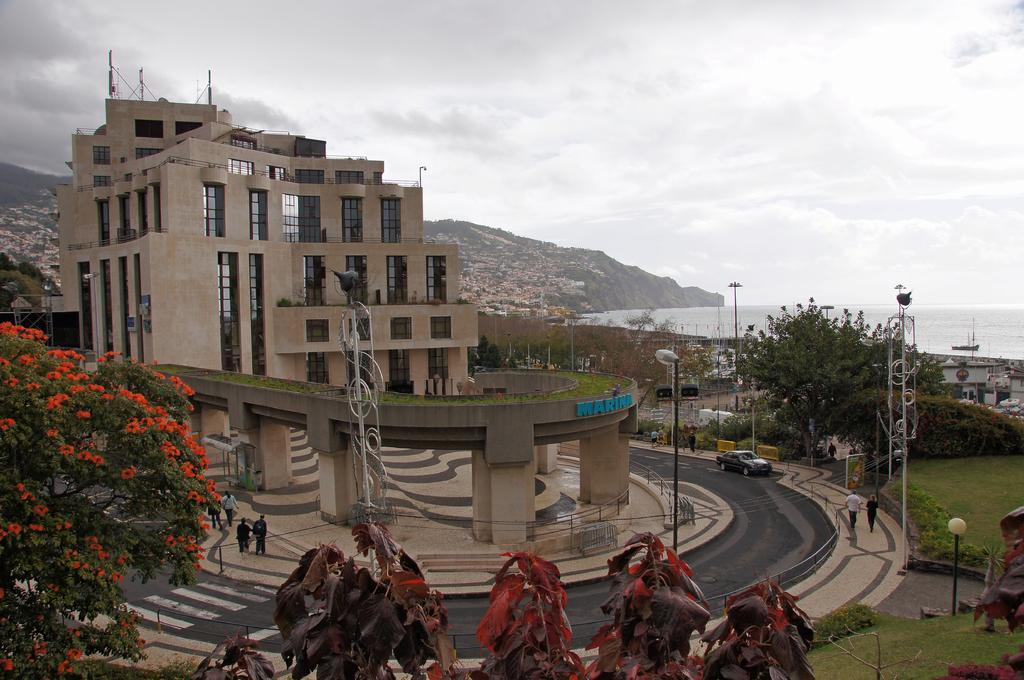What type of vegetation can be seen in the image? There are trees, flowers, and grass visible in the image. What man-made structure is present in the image? There is a road and a building visible in the image. Can you describe the people in the image? There are people present in the image, but their specific actions or characteristics are not mentioned in the facts. What is the lighting situation in the image? There are lights on poles in the image. What can be seen in the background of the image? There is a hill, trees, a building, a ship above the water, and sky visible in the background of the image. What is the weather like in the image? The presence of clouds in the sky suggests that it might be partly cloudy. What is the purpose of the celery in the image? There is no celery present in the image. Can you tell me how many people made the request for the ship to be in the background of the image? There is no information about a request for the ship to be in the background of the image, and therefore no such information can be provided. 